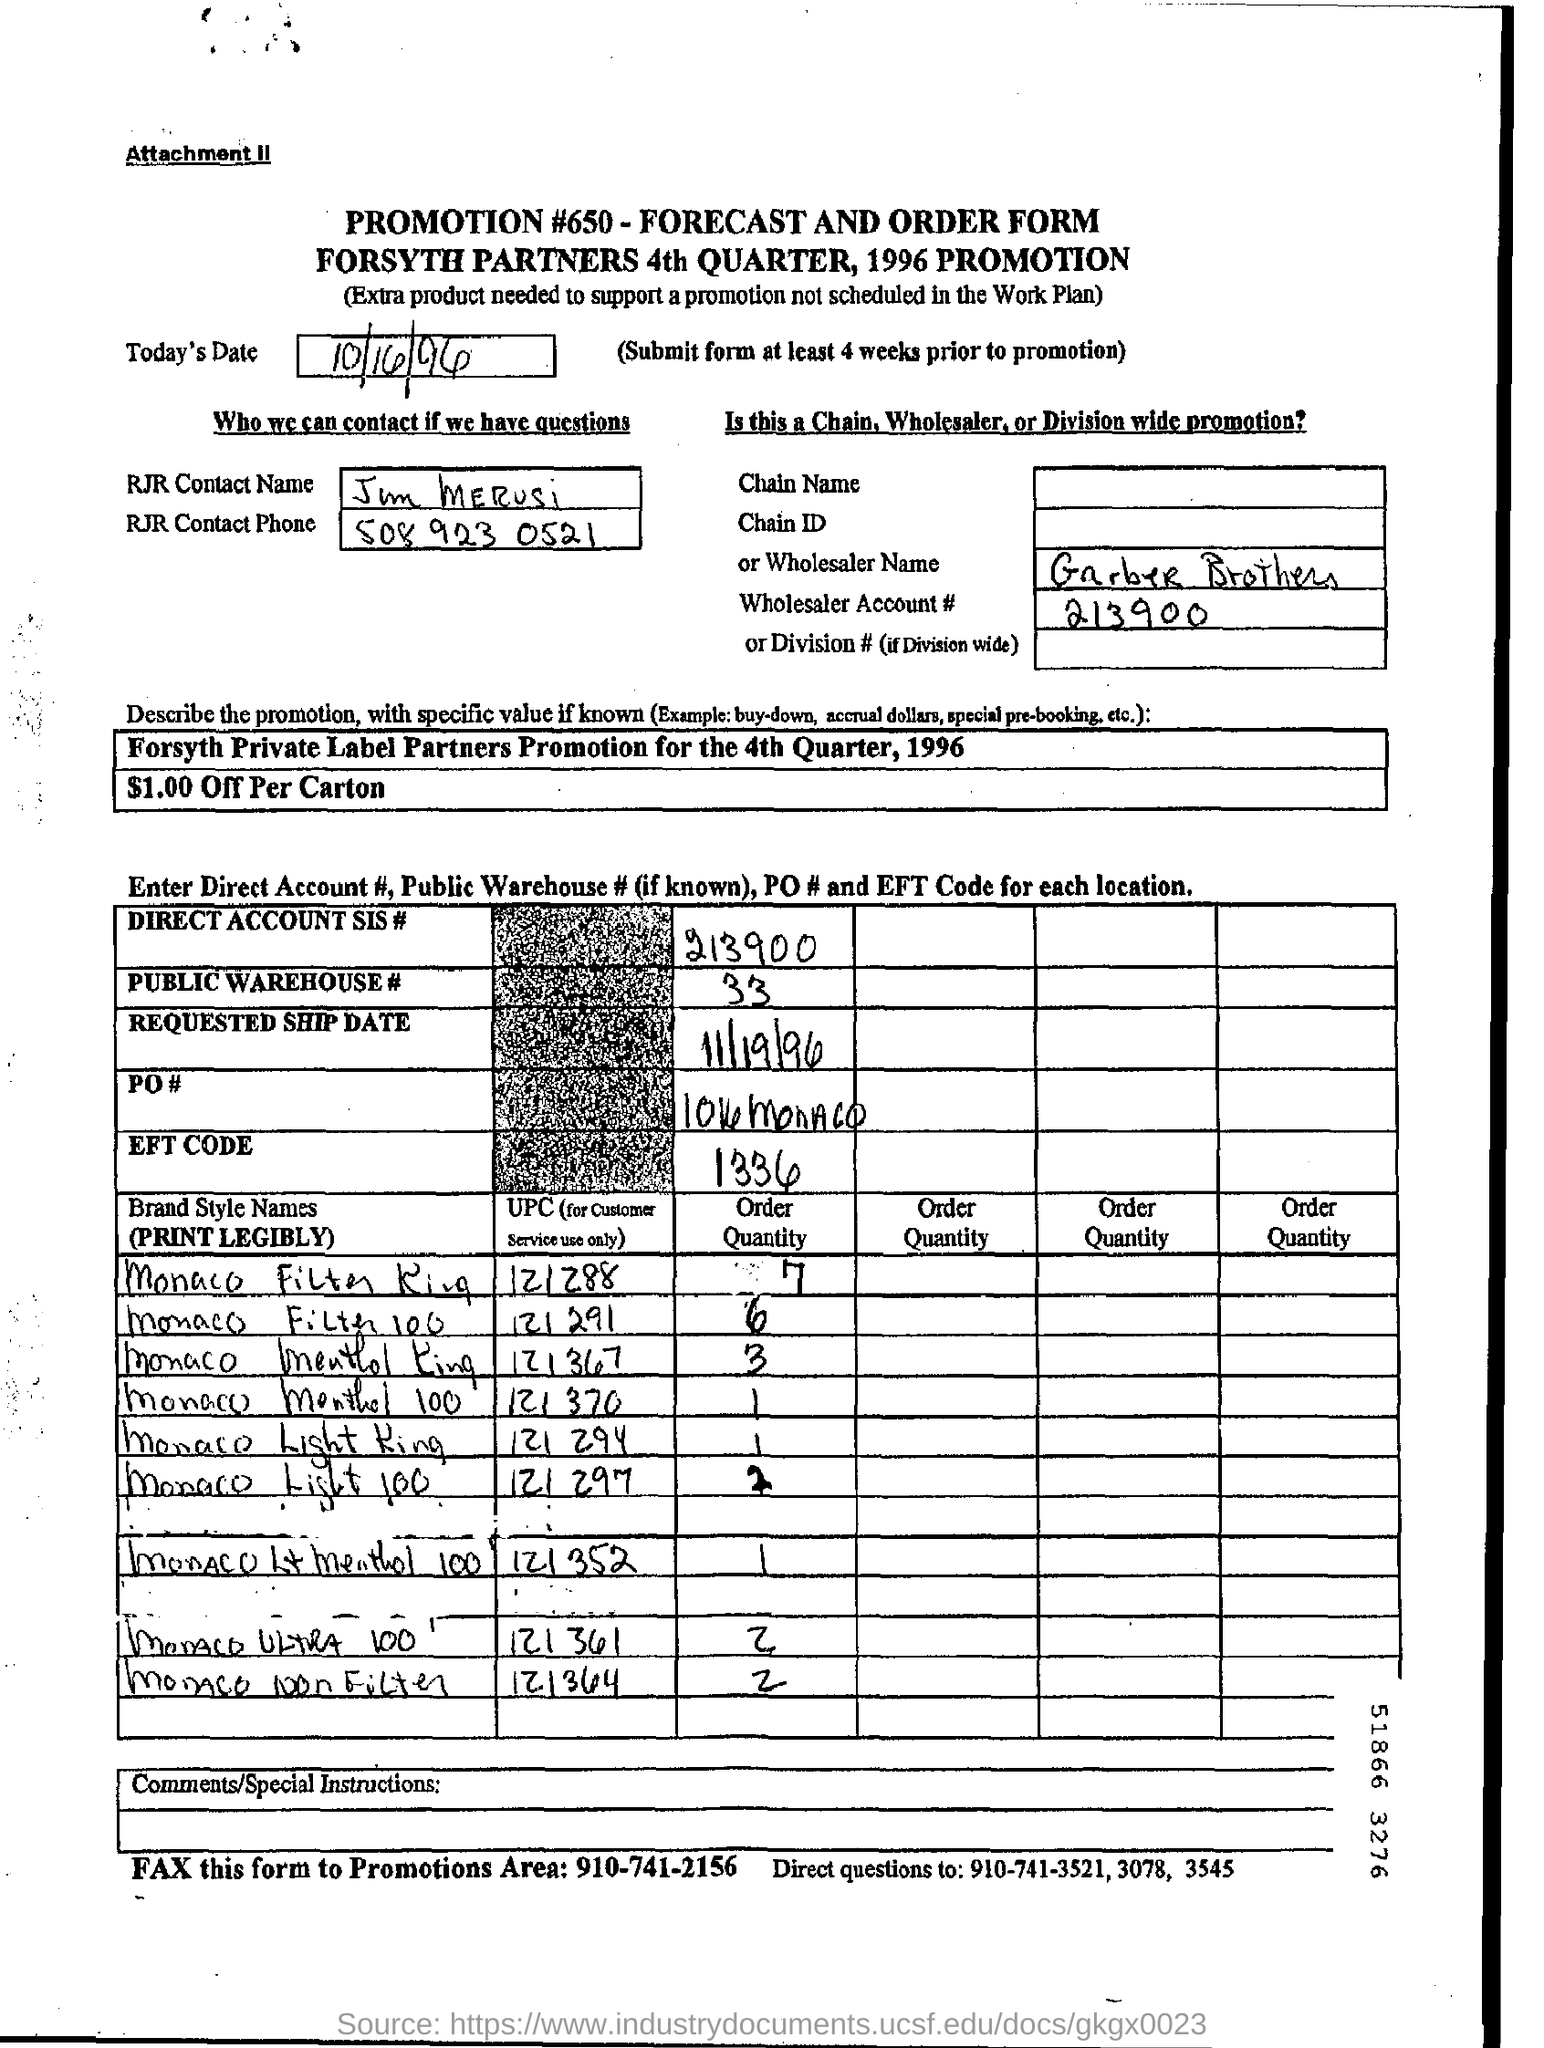Identify some key points in this picture. What is the direct account SIS number?" is a question that can be answered by providing the numerical answer "213900... Please provide the Wholesaler Account Number, which is 213900... The requested ship date is 11/19/96. What is the EFT code? It is 1336... 